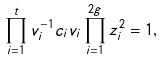Convert formula to latex. <formula><loc_0><loc_0><loc_500><loc_500>\prod _ { i = 1 } ^ { t } v _ { i } ^ { - 1 } c _ { i } v _ { i } \prod _ { i = 1 } ^ { 2 g } z _ { i } ^ { 2 } = 1 ,</formula> 